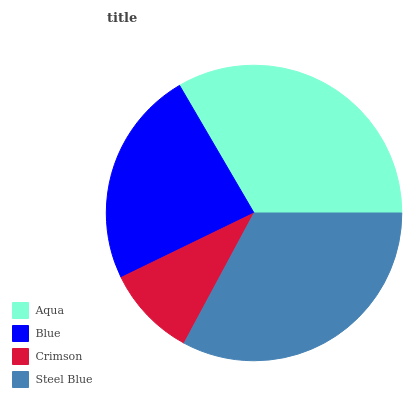Is Crimson the minimum?
Answer yes or no. Yes. Is Aqua the maximum?
Answer yes or no. Yes. Is Blue the minimum?
Answer yes or no. No. Is Blue the maximum?
Answer yes or no. No. Is Aqua greater than Blue?
Answer yes or no. Yes. Is Blue less than Aqua?
Answer yes or no. Yes. Is Blue greater than Aqua?
Answer yes or no. No. Is Aqua less than Blue?
Answer yes or no. No. Is Steel Blue the high median?
Answer yes or no. Yes. Is Blue the low median?
Answer yes or no. Yes. Is Aqua the high median?
Answer yes or no. No. Is Aqua the low median?
Answer yes or no. No. 